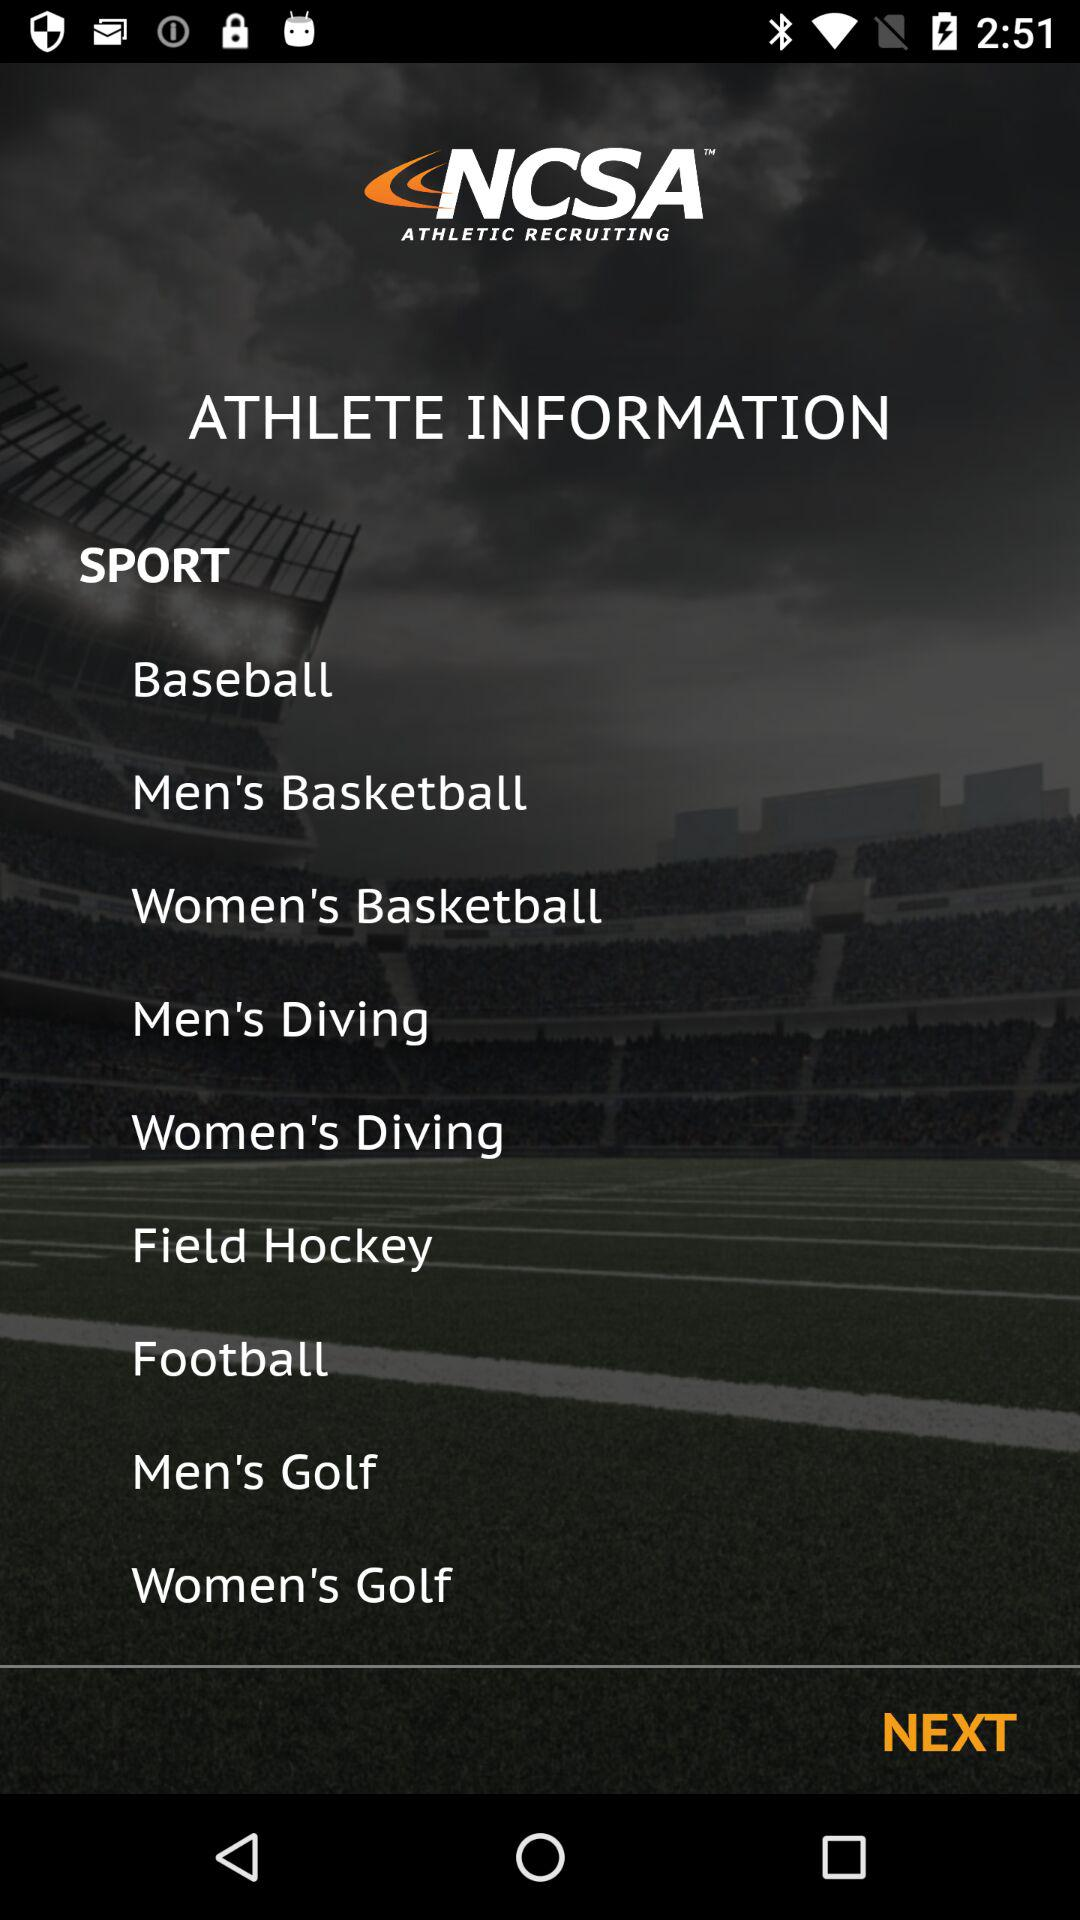What is the application name? The name of the application is "NCSA ATHLETIC RECRUITING". 